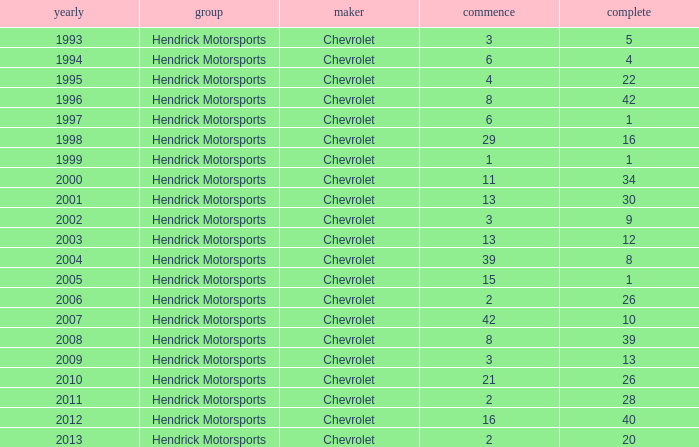Which team had a start of 8 in years under 2008? Hendrick Motorsports. 